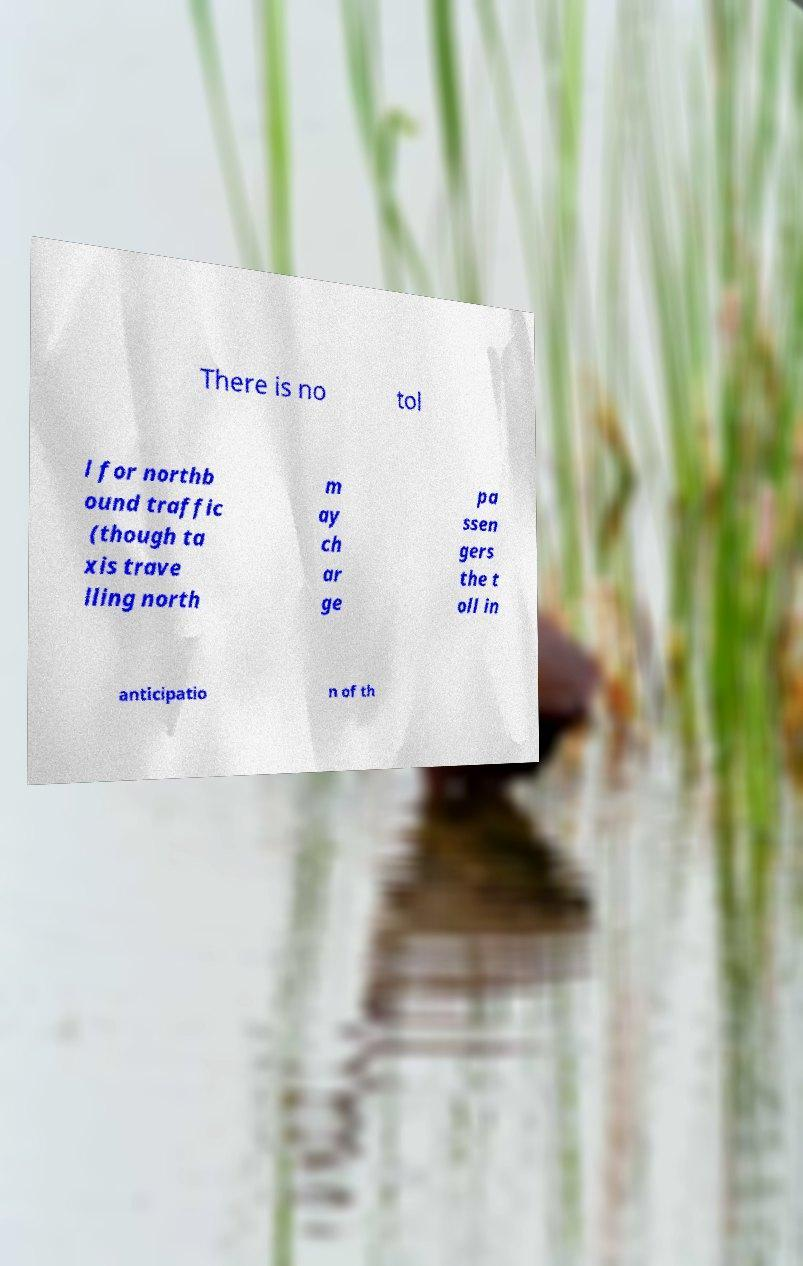I need the written content from this picture converted into text. Can you do that? There is no tol l for northb ound traffic (though ta xis trave lling north m ay ch ar ge pa ssen gers the t oll in anticipatio n of th 